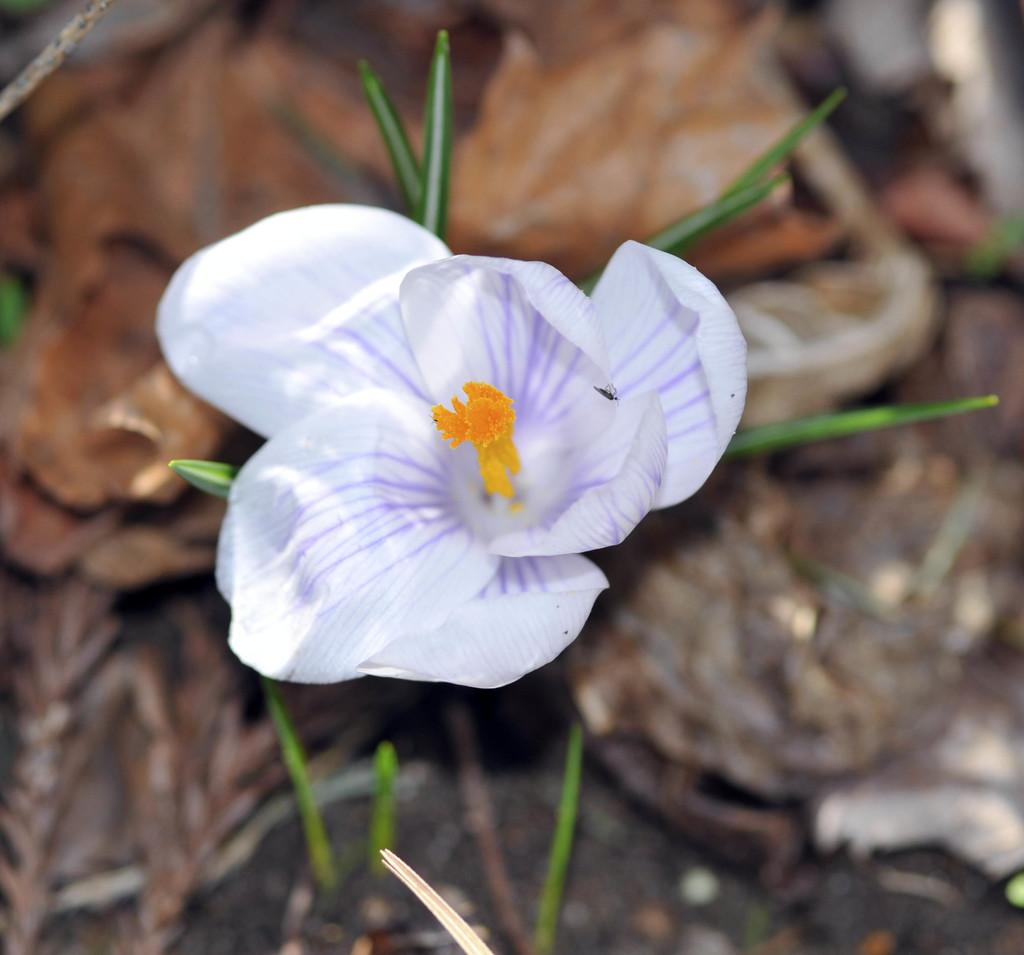What type of plant can be seen in the image? There is a flower in the image. What part of the flower is visible in the image? The flower itself is visible in the image. Are there any other parts of the plant visible in the image? Yes, there are leaves associated with the flower in the image. What type of camera can be seen taking a picture of the flower in the image? There is no camera present in the image; it only features a flower and its leaves. Is there a slope visible in the image? There is no slope present in the image. 